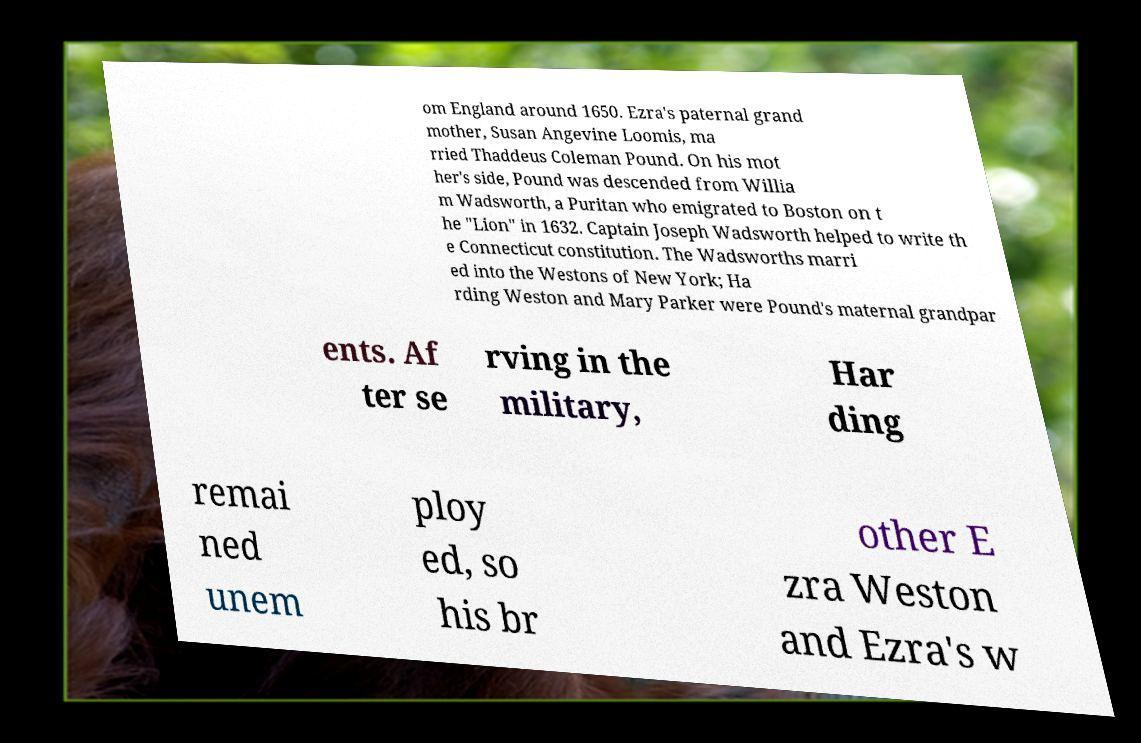Could you assist in decoding the text presented in this image and type it out clearly? om England around 1650. Ezra's paternal grand mother, Susan Angevine Loomis, ma rried Thaddeus Coleman Pound. On his mot her's side, Pound was descended from Willia m Wadsworth, a Puritan who emigrated to Boston on t he "Lion" in 1632. Captain Joseph Wadsworth helped to write th e Connecticut constitution. The Wadsworths marri ed into the Westons of New York; Ha rding Weston and Mary Parker were Pound's maternal grandpar ents. Af ter se rving in the military, Har ding remai ned unem ploy ed, so his br other E zra Weston and Ezra's w 